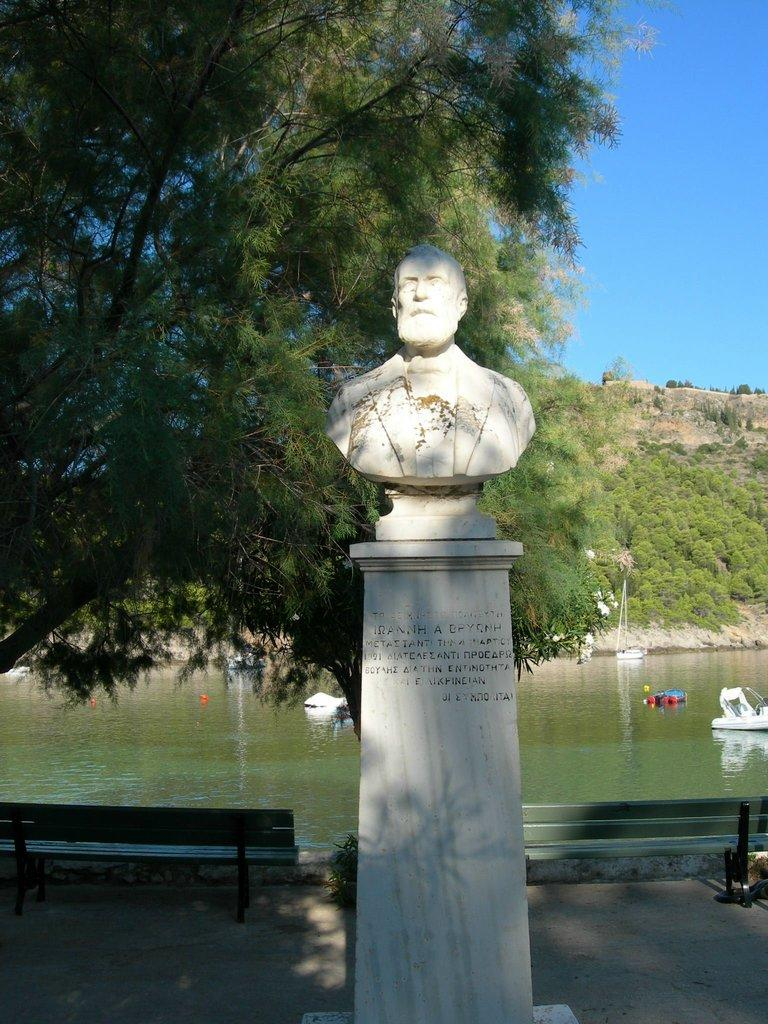What is the main object in the image? There is a statue in the image. What other objects can be seen in the image? There is a tree, a bench, a boat, and water in the image. What is the color of the sky in the image? The sky is blue in the image. What type of scent can be detected from the statue in the image? There is no information about a scent in the image, as it only provides visual details. 